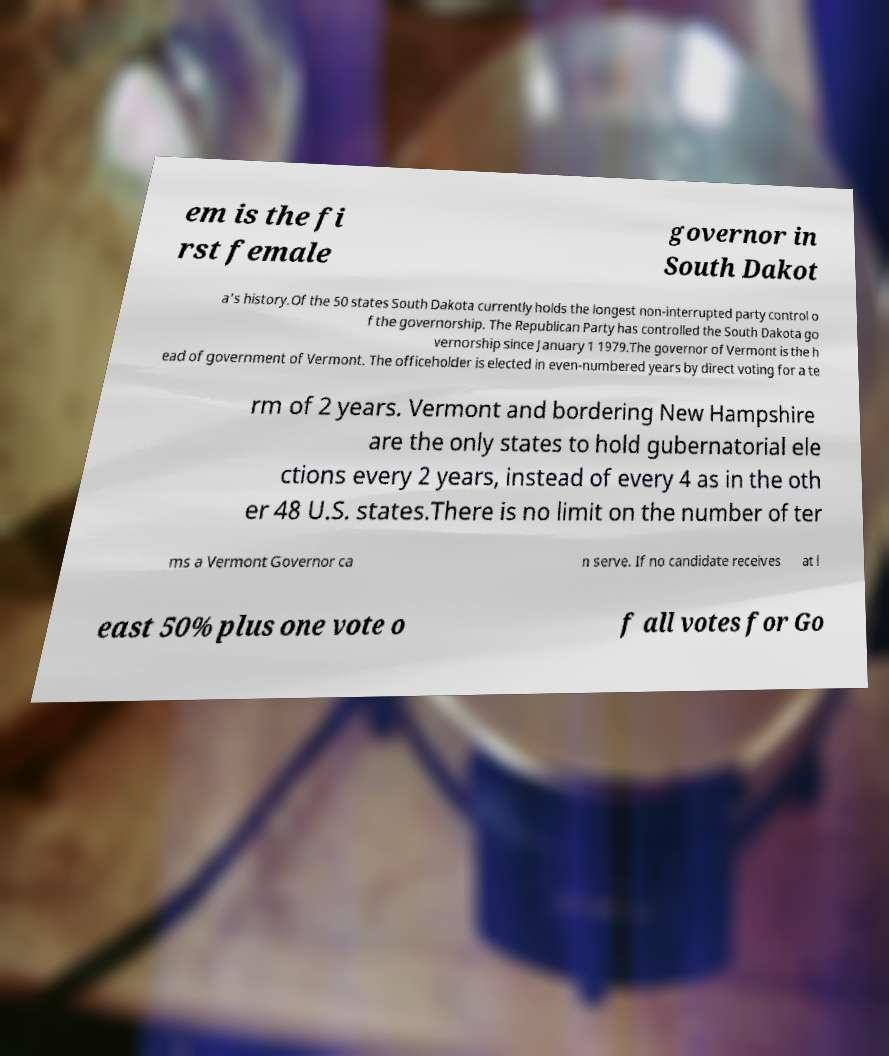There's text embedded in this image that I need extracted. Can you transcribe it verbatim? em is the fi rst female governor in South Dakot a's history.Of the 50 states South Dakota currently holds the longest non-interrupted party control o f the governorship. The Republican Party has controlled the South Dakota go vernorship since January 1 1979.The governor of Vermont is the h ead of government of Vermont. The officeholder is elected in even-numbered years by direct voting for a te rm of 2 years. Vermont and bordering New Hampshire are the only states to hold gubernatorial ele ctions every 2 years, instead of every 4 as in the oth er 48 U.S. states.There is no limit on the number of ter ms a Vermont Governor ca n serve. If no candidate receives at l east 50% plus one vote o f all votes for Go 